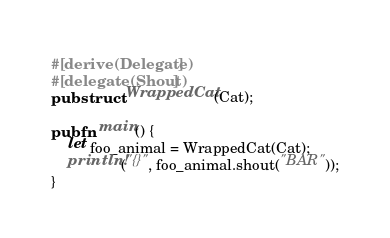<code> <loc_0><loc_0><loc_500><loc_500><_Rust_>
#[derive(Delegate)]
#[delegate(Shout)]
pub struct WrappedCat(Cat);

pub fn main() {
    let foo_animal = WrappedCat(Cat);
    println!("{}", foo_animal.shout("BAR"));
}
</code> 